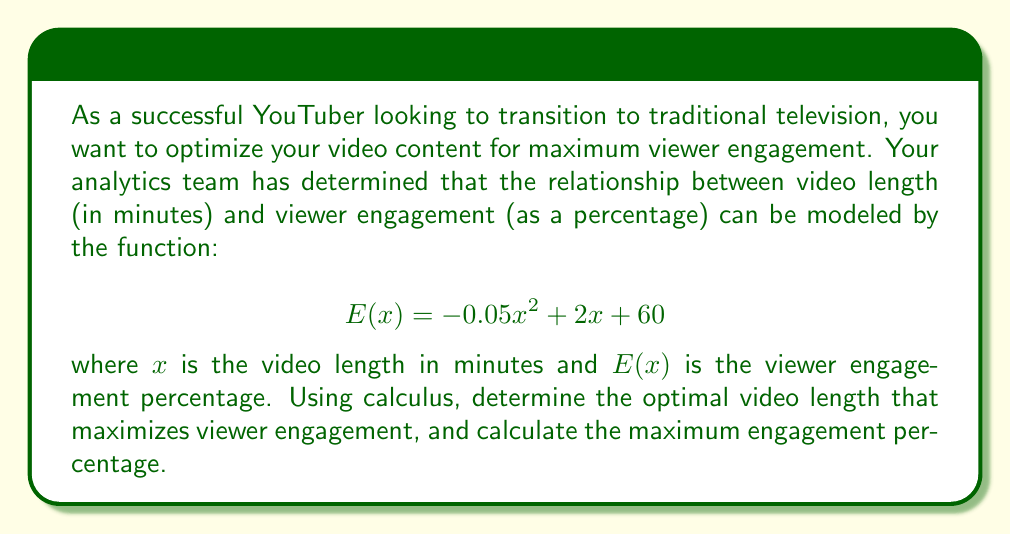Teach me how to tackle this problem. To solve this problem, we'll use the following steps:

1) The maximum of a function occurs at a critical point where the derivative is zero or undefined. In this case, we need to find where the derivative is zero.

2) First, let's find the derivative of $E(x)$:
   $$E'(x) = \frac{d}{dx}(-0.05x^2 + 2x + 60)$$
   $$E'(x) = -0.1x + 2$$

3) Now, let's set the derivative equal to zero and solve for $x$:
   $$-0.1x + 2 = 0$$
   $$-0.1x = -2$$
   $$x = 20$$

4) To confirm this is a maximum (not a minimum), we can check the second derivative:
   $$E''(x) = -0.1$$
   Since $E''(x)$ is negative, we confirm that $x = 20$ gives a maximum.

5) To find the maximum engagement percentage, we plug $x = 20$ back into our original function:
   $$E(20) = -0.05(20)^2 + 2(20) + 60$$
   $$= -0.05(400) + 40 + 60$$
   $$= -20 + 40 + 60$$
   $$= 80$$

Therefore, the optimal video length is 20 minutes, which results in a maximum viewer engagement of 80%.
Answer: The optimal video length is 20 minutes, resulting in a maximum viewer engagement of 80%. 